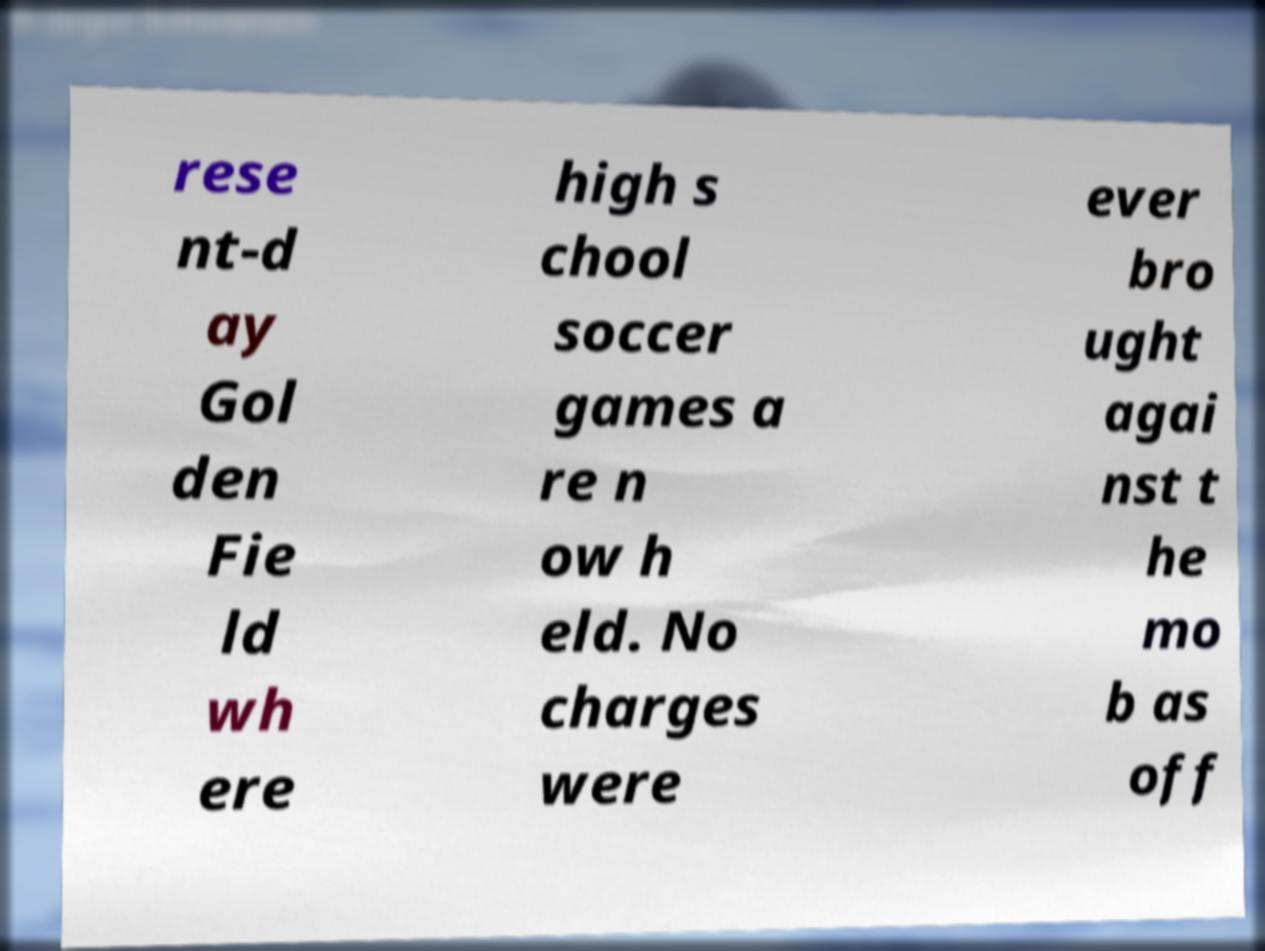Please read and relay the text visible in this image. What does it say? rese nt-d ay Gol den Fie ld wh ere high s chool soccer games a re n ow h eld. No charges were ever bro ught agai nst t he mo b as off 